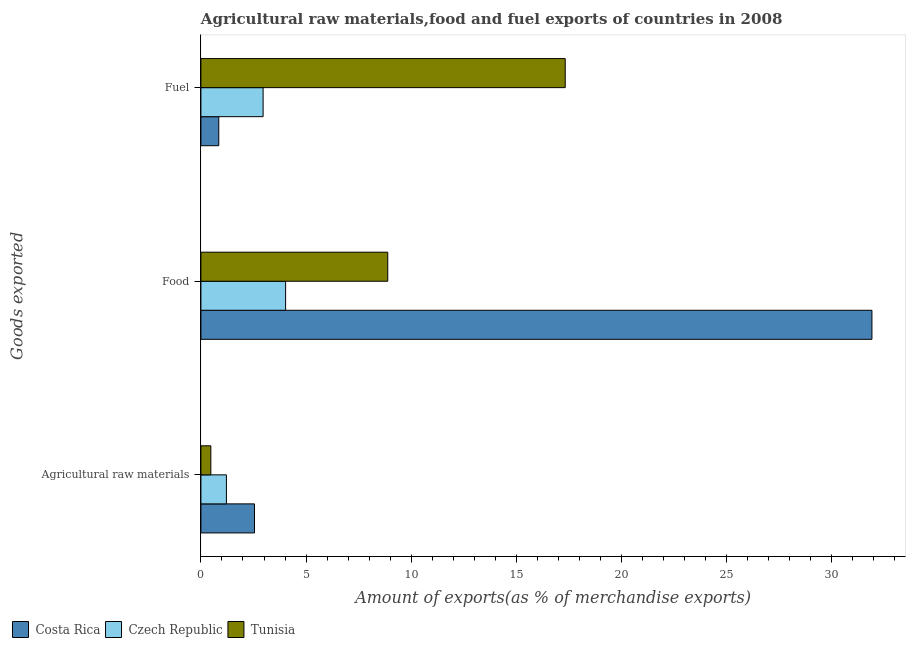How many different coloured bars are there?
Your answer should be compact. 3. How many groups of bars are there?
Give a very brief answer. 3. Are the number of bars per tick equal to the number of legend labels?
Offer a very short reply. Yes. Are the number of bars on each tick of the Y-axis equal?
Keep it short and to the point. Yes. How many bars are there on the 3rd tick from the top?
Give a very brief answer. 3. What is the label of the 3rd group of bars from the top?
Your answer should be very brief. Agricultural raw materials. What is the percentage of raw materials exports in Costa Rica?
Provide a short and direct response. 2.55. Across all countries, what is the maximum percentage of fuel exports?
Offer a very short reply. 17.32. Across all countries, what is the minimum percentage of food exports?
Provide a short and direct response. 4.03. In which country was the percentage of fuel exports maximum?
Offer a very short reply. Tunisia. In which country was the percentage of raw materials exports minimum?
Offer a very short reply. Tunisia. What is the total percentage of raw materials exports in the graph?
Offer a terse response. 4.23. What is the difference between the percentage of raw materials exports in Costa Rica and that in Czech Republic?
Make the answer very short. 1.34. What is the difference between the percentage of raw materials exports in Czech Republic and the percentage of fuel exports in Costa Rica?
Provide a succinct answer. 0.36. What is the average percentage of raw materials exports per country?
Make the answer very short. 1.41. What is the difference between the percentage of fuel exports and percentage of raw materials exports in Tunisia?
Provide a short and direct response. 16.85. What is the ratio of the percentage of food exports in Costa Rica to that in Czech Republic?
Give a very brief answer. 7.92. Is the percentage of fuel exports in Costa Rica less than that in Czech Republic?
Provide a short and direct response. Yes. Is the difference between the percentage of raw materials exports in Tunisia and Costa Rica greater than the difference between the percentage of food exports in Tunisia and Costa Rica?
Your answer should be very brief. Yes. What is the difference between the highest and the second highest percentage of raw materials exports?
Provide a succinct answer. 1.34. What is the difference between the highest and the lowest percentage of raw materials exports?
Provide a succinct answer. 2.08. In how many countries, is the percentage of food exports greater than the average percentage of food exports taken over all countries?
Ensure brevity in your answer.  1. Is the sum of the percentage of food exports in Czech Republic and Costa Rica greater than the maximum percentage of raw materials exports across all countries?
Provide a succinct answer. Yes. What does the 1st bar from the top in Fuel represents?
Keep it short and to the point. Tunisia. What does the 1st bar from the bottom in Fuel represents?
Give a very brief answer. Costa Rica. How many countries are there in the graph?
Offer a terse response. 3. What is the difference between two consecutive major ticks on the X-axis?
Keep it short and to the point. 5. Does the graph contain any zero values?
Give a very brief answer. No. Does the graph contain grids?
Your answer should be very brief. No. Where does the legend appear in the graph?
Offer a very short reply. Bottom left. How are the legend labels stacked?
Offer a very short reply. Horizontal. What is the title of the graph?
Make the answer very short. Agricultural raw materials,food and fuel exports of countries in 2008. What is the label or title of the X-axis?
Offer a very short reply. Amount of exports(as % of merchandise exports). What is the label or title of the Y-axis?
Keep it short and to the point. Goods exported. What is the Amount of exports(as % of merchandise exports) in Costa Rica in Agricultural raw materials?
Make the answer very short. 2.55. What is the Amount of exports(as % of merchandise exports) in Czech Republic in Agricultural raw materials?
Give a very brief answer. 1.21. What is the Amount of exports(as % of merchandise exports) of Tunisia in Agricultural raw materials?
Offer a terse response. 0.47. What is the Amount of exports(as % of merchandise exports) of Costa Rica in Food?
Offer a terse response. 31.91. What is the Amount of exports(as % of merchandise exports) in Czech Republic in Food?
Your answer should be compact. 4.03. What is the Amount of exports(as % of merchandise exports) in Tunisia in Food?
Provide a succinct answer. 8.88. What is the Amount of exports(as % of merchandise exports) in Costa Rica in Fuel?
Your answer should be very brief. 0.85. What is the Amount of exports(as % of merchandise exports) in Czech Republic in Fuel?
Offer a terse response. 2.96. What is the Amount of exports(as % of merchandise exports) in Tunisia in Fuel?
Provide a short and direct response. 17.32. Across all Goods exported, what is the maximum Amount of exports(as % of merchandise exports) of Costa Rica?
Make the answer very short. 31.91. Across all Goods exported, what is the maximum Amount of exports(as % of merchandise exports) of Czech Republic?
Keep it short and to the point. 4.03. Across all Goods exported, what is the maximum Amount of exports(as % of merchandise exports) of Tunisia?
Offer a terse response. 17.32. Across all Goods exported, what is the minimum Amount of exports(as % of merchandise exports) of Costa Rica?
Give a very brief answer. 0.85. Across all Goods exported, what is the minimum Amount of exports(as % of merchandise exports) of Czech Republic?
Offer a very short reply. 1.21. Across all Goods exported, what is the minimum Amount of exports(as % of merchandise exports) of Tunisia?
Your answer should be very brief. 0.47. What is the total Amount of exports(as % of merchandise exports) in Costa Rica in the graph?
Keep it short and to the point. 35.31. What is the total Amount of exports(as % of merchandise exports) of Czech Republic in the graph?
Provide a succinct answer. 8.2. What is the total Amount of exports(as % of merchandise exports) of Tunisia in the graph?
Provide a short and direct response. 26.68. What is the difference between the Amount of exports(as % of merchandise exports) in Costa Rica in Agricultural raw materials and that in Food?
Provide a short and direct response. -29.36. What is the difference between the Amount of exports(as % of merchandise exports) in Czech Republic in Agricultural raw materials and that in Food?
Keep it short and to the point. -2.81. What is the difference between the Amount of exports(as % of merchandise exports) of Tunisia in Agricultural raw materials and that in Food?
Give a very brief answer. -8.41. What is the difference between the Amount of exports(as % of merchandise exports) in Costa Rica in Agricultural raw materials and that in Fuel?
Provide a succinct answer. 1.7. What is the difference between the Amount of exports(as % of merchandise exports) of Czech Republic in Agricultural raw materials and that in Fuel?
Offer a very short reply. -1.75. What is the difference between the Amount of exports(as % of merchandise exports) of Tunisia in Agricultural raw materials and that in Fuel?
Your answer should be very brief. -16.85. What is the difference between the Amount of exports(as % of merchandise exports) of Costa Rica in Food and that in Fuel?
Provide a succinct answer. 31.06. What is the difference between the Amount of exports(as % of merchandise exports) of Czech Republic in Food and that in Fuel?
Provide a succinct answer. 1.07. What is the difference between the Amount of exports(as % of merchandise exports) of Tunisia in Food and that in Fuel?
Provide a short and direct response. -8.44. What is the difference between the Amount of exports(as % of merchandise exports) in Costa Rica in Agricultural raw materials and the Amount of exports(as % of merchandise exports) in Czech Republic in Food?
Provide a short and direct response. -1.48. What is the difference between the Amount of exports(as % of merchandise exports) in Costa Rica in Agricultural raw materials and the Amount of exports(as % of merchandise exports) in Tunisia in Food?
Offer a terse response. -6.34. What is the difference between the Amount of exports(as % of merchandise exports) in Czech Republic in Agricultural raw materials and the Amount of exports(as % of merchandise exports) in Tunisia in Food?
Make the answer very short. -7.67. What is the difference between the Amount of exports(as % of merchandise exports) in Costa Rica in Agricultural raw materials and the Amount of exports(as % of merchandise exports) in Czech Republic in Fuel?
Ensure brevity in your answer.  -0.41. What is the difference between the Amount of exports(as % of merchandise exports) of Costa Rica in Agricultural raw materials and the Amount of exports(as % of merchandise exports) of Tunisia in Fuel?
Offer a very short reply. -14.78. What is the difference between the Amount of exports(as % of merchandise exports) in Czech Republic in Agricultural raw materials and the Amount of exports(as % of merchandise exports) in Tunisia in Fuel?
Give a very brief answer. -16.11. What is the difference between the Amount of exports(as % of merchandise exports) in Costa Rica in Food and the Amount of exports(as % of merchandise exports) in Czech Republic in Fuel?
Keep it short and to the point. 28.95. What is the difference between the Amount of exports(as % of merchandise exports) in Costa Rica in Food and the Amount of exports(as % of merchandise exports) in Tunisia in Fuel?
Provide a succinct answer. 14.59. What is the difference between the Amount of exports(as % of merchandise exports) of Czech Republic in Food and the Amount of exports(as % of merchandise exports) of Tunisia in Fuel?
Ensure brevity in your answer.  -13.3. What is the average Amount of exports(as % of merchandise exports) in Costa Rica per Goods exported?
Make the answer very short. 11.77. What is the average Amount of exports(as % of merchandise exports) in Czech Republic per Goods exported?
Provide a short and direct response. 2.73. What is the average Amount of exports(as % of merchandise exports) of Tunisia per Goods exported?
Make the answer very short. 8.89. What is the difference between the Amount of exports(as % of merchandise exports) of Costa Rica and Amount of exports(as % of merchandise exports) of Czech Republic in Agricultural raw materials?
Provide a short and direct response. 1.34. What is the difference between the Amount of exports(as % of merchandise exports) in Costa Rica and Amount of exports(as % of merchandise exports) in Tunisia in Agricultural raw materials?
Provide a short and direct response. 2.08. What is the difference between the Amount of exports(as % of merchandise exports) of Czech Republic and Amount of exports(as % of merchandise exports) of Tunisia in Agricultural raw materials?
Your answer should be very brief. 0.74. What is the difference between the Amount of exports(as % of merchandise exports) of Costa Rica and Amount of exports(as % of merchandise exports) of Czech Republic in Food?
Your response must be concise. 27.88. What is the difference between the Amount of exports(as % of merchandise exports) of Costa Rica and Amount of exports(as % of merchandise exports) of Tunisia in Food?
Ensure brevity in your answer.  23.02. What is the difference between the Amount of exports(as % of merchandise exports) of Czech Republic and Amount of exports(as % of merchandise exports) of Tunisia in Food?
Keep it short and to the point. -4.86. What is the difference between the Amount of exports(as % of merchandise exports) of Costa Rica and Amount of exports(as % of merchandise exports) of Czech Republic in Fuel?
Provide a short and direct response. -2.11. What is the difference between the Amount of exports(as % of merchandise exports) of Costa Rica and Amount of exports(as % of merchandise exports) of Tunisia in Fuel?
Give a very brief answer. -16.48. What is the difference between the Amount of exports(as % of merchandise exports) in Czech Republic and Amount of exports(as % of merchandise exports) in Tunisia in Fuel?
Your response must be concise. -14.37. What is the ratio of the Amount of exports(as % of merchandise exports) of Costa Rica in Agricultural raw materials to that in Food?
Ensure brevity in your answer.  0.08. What is the ratio of the Amount of exports(as % of merchandise exports) of Czech Republic in Agricultural raw materials to that in Food?
Offer a very short reply. 0.3. What is the ratio of the Amount of exports(as % of merchandise exports) in Tunisia in Agricultural raw materials to that in Food?
Your answer should be compact. 0.05. What is the ratio of the Amount of exports(as % of merchandise exports) of Costa Rica in Agricultural raw materials to that in Fuel?
Your answer should be very brief. 3. What is the ratio of the Amount of exports(as % of merchandise exports) in Czech Republic in Agricultural raw materials to that in Fuel?
Provide a succinct answer. 0.41. What is the ratio of the Amount of exports(as % of merchandise exports) in Tunisia in Agricultural raw materials to that in Fuel?
Your answer should be very brief. 0.03. What is the ratio of the Amount of exports(as % of merchandise exports) of Costa Rica in Food to that in Fuel?
Your answer should be compact. 37.6. What is the ratio of the Amount of exports(as % of merchandise exports) of Czech Republic in Food to that in Fuel?
Provide a succinct answer. 1.36. What is the ratio of the Amount of exports(as % of merchandise exports) in Tunisia in Food to that in Fuel?
Your answer should be compact. 0.51. What is the difference between the highest and the second highest Amount of exports(as % of merchandise exports) of Costa Rica?
Offer a terse response. 29.36. What is the difference between the highest and the second highest Amount of exports(as % of merchandise exports) of Czech Republic?
Ensure brevity in your answer.  1.07. What is the difference between the highest and the second highest Amount of exports(as % of merchandise exports) in Tunisia?
Offer a terse response. 8.44. What is the difference between the highest and the lowest Amount of exports(as % of merchandise exports) in Costa Rica?
Offer a terse response. 31.06. What is the difference between the highest and the lowest Amount of exports(as % of merchandise exports) in Czech Republic?
Keep it short and to the point. 2.81. What is the difference between the highest and the lowest Amount of exports(as % of merchandise exports) in Tunisia?
Your answer should be compact. 16.85. 